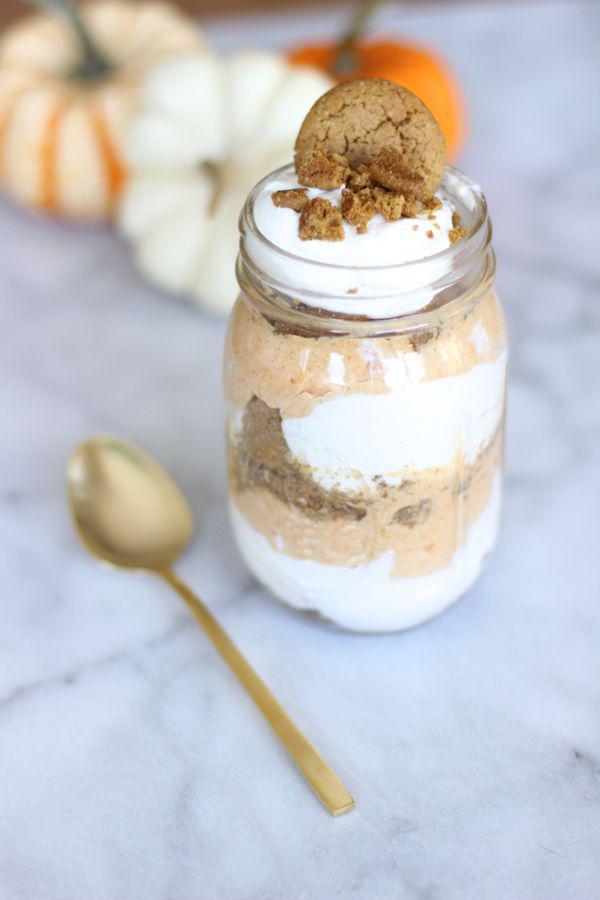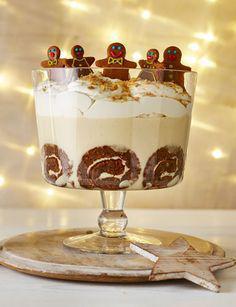The first image is the image on the left, the second image is the image on the right. Evaluate the accuracy of this statement regarding the images: "An image shows a creamy layered dessert with one row of brown shapes arranged inside the glass of the footed serving bowl.". Is it true? Answer yes or no. Yes. The first image is the image on the left, the second image is the image on the right. Evaluate the accuracy of this statement regarding the images: "In one image, a large creamy dessert is displayed in a clear footed bowl, while a second image shows at least one individual dessert with the same number of spoons.". Is it true? Answer yes or no. Yes. 